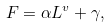Convert formula to latex. <formula><loc_0><loc_0><loc_500><loc_500>F = \alpha L ^ { v } + \gamma ,</formula> 